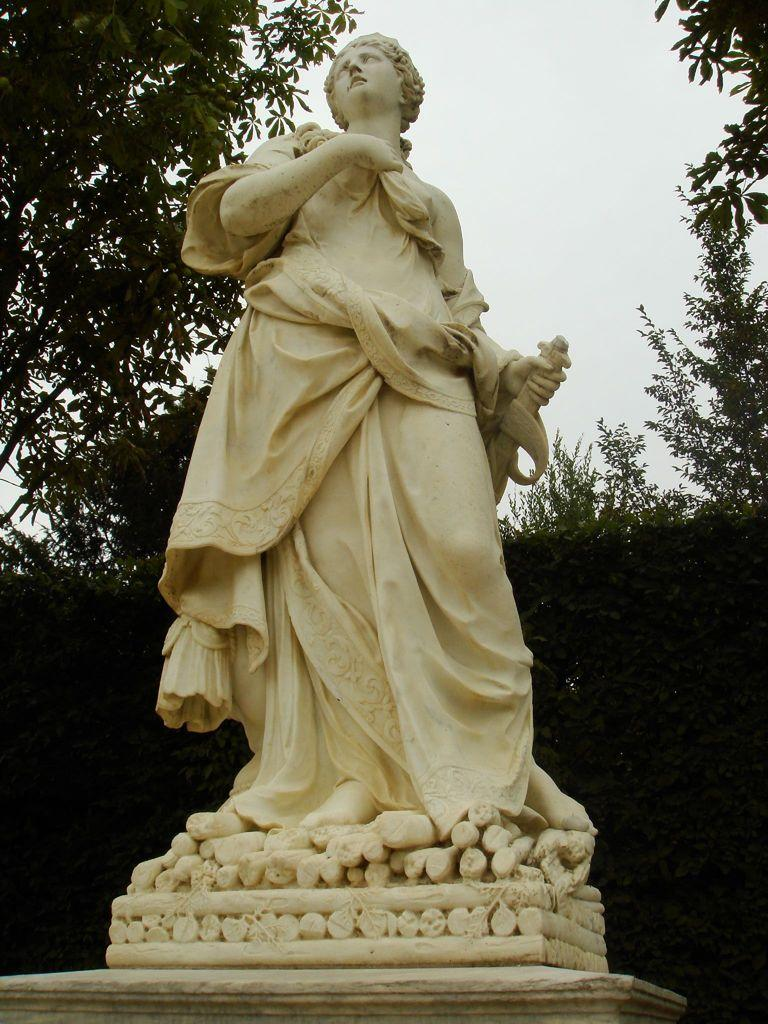What type of statue is depicted in the image? There is a stone carved statue of a woman in the image. What is the woman holding in the statue? The woman is holding a sword. What can be seen in the background of the image? There are trees in the background of the image. What is visible at the top of the image? The sky is visible at the top of the image. What type of weather can be seen in the image? The image does not depict any weather conditions; it only shows a stone carved statue of a woman, trees in the background, and the sky. What function does the calculator serve in the image? There is no calculator present in the image. 